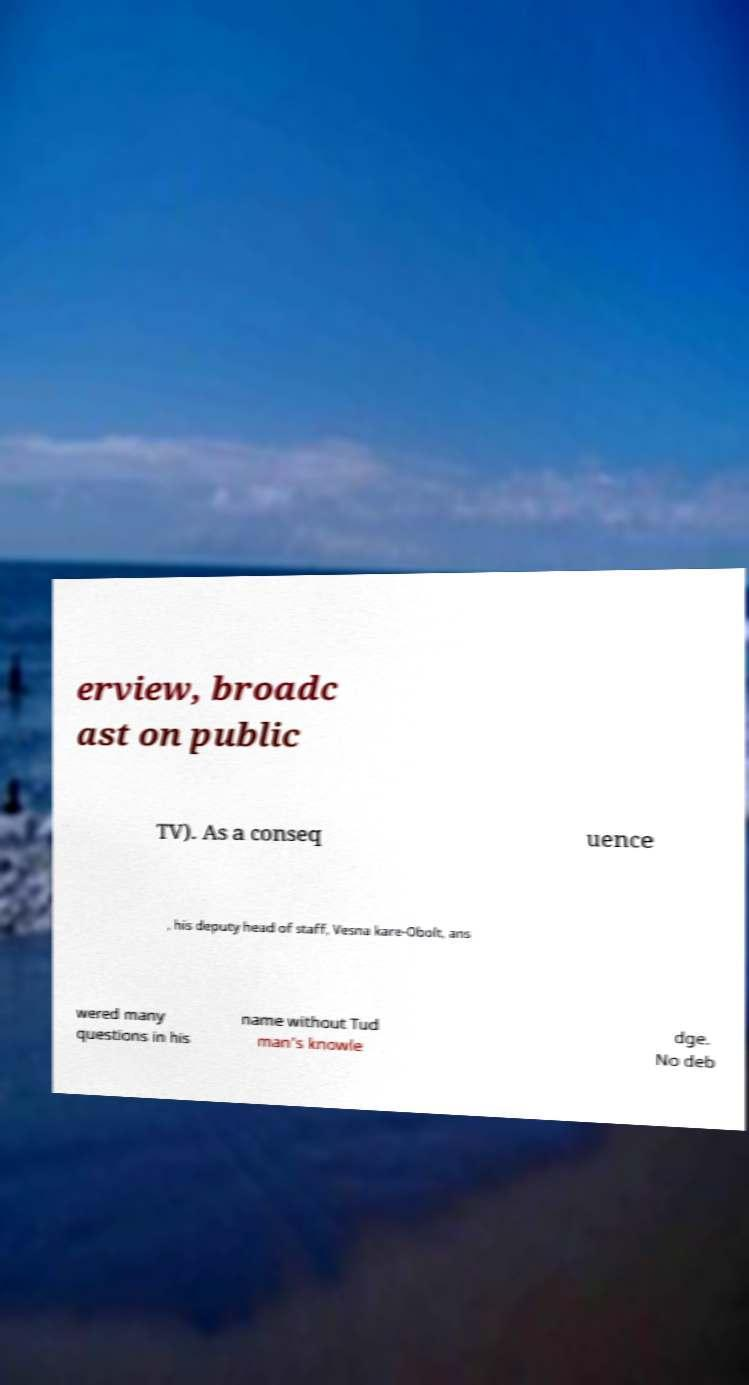I need the written content from this picture converted into text. Can you do that? erview, broadc ast on public TV). As a conseq uence , his deputy head of staff, Vesna kare-Obolt, ans wered many questions in his name without Tud man's knowle dge. No deb 